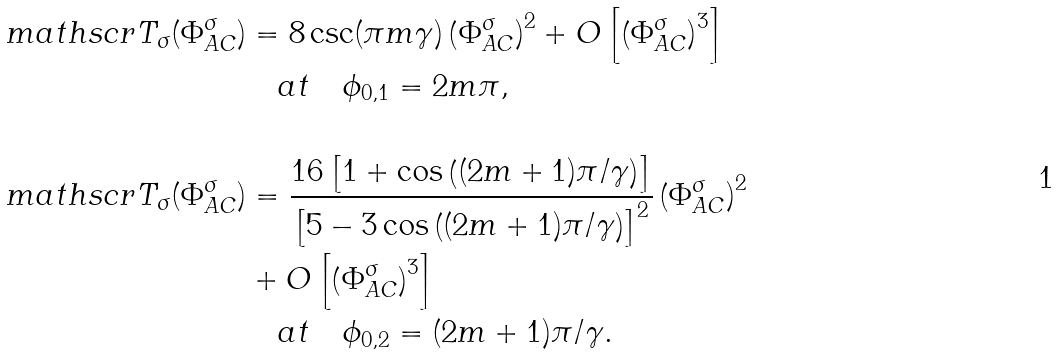<formula> <loc_0><loc_0><loc_500><loc_500>\ m a t h s c r { T } _ { \sigma } ( \Phi _ { A C } ^ { \sigma } ) & = 8 \csc ( \pi m \gamma ) \left ( \Phi _ { A C } ^ { \sigma } \right ) ^ { 2 } + O \left [ \left ( \Phi _ { A C } ^ { \sigma } \right ) ^ { 3 } \right ] \\ & \quad a t \quad \phi _ { 0 , 1 } = 2 m \pi , \\ \\ \ m a t h s c r { T } _ { \sigma } ( \Phi _ { A C } ^ { \sigma } ) & = \frac { 1 6 \left [ 1 + \cos \left ( ( 2 m + 1 ) \pi / \gamma \right ) \right ] } { \left [ 5 - 3 \cos \left ( ( 2 m + 1 ) \pi / \gamma \right ) \right ] ^ { 2 } } \left ( \Phi _ { A C } ^ { \sigma } \right ) ^ { 2 } \\ & + O \left [ \left ( \Phi _ { A C } ^ { \sigma } \right ) ^ { 3 } \right ] \\ & \quad a t \quad \phi _ { 0 , 2 } = ( 2 m + 1 ) \pi / \gamma .</formula> 